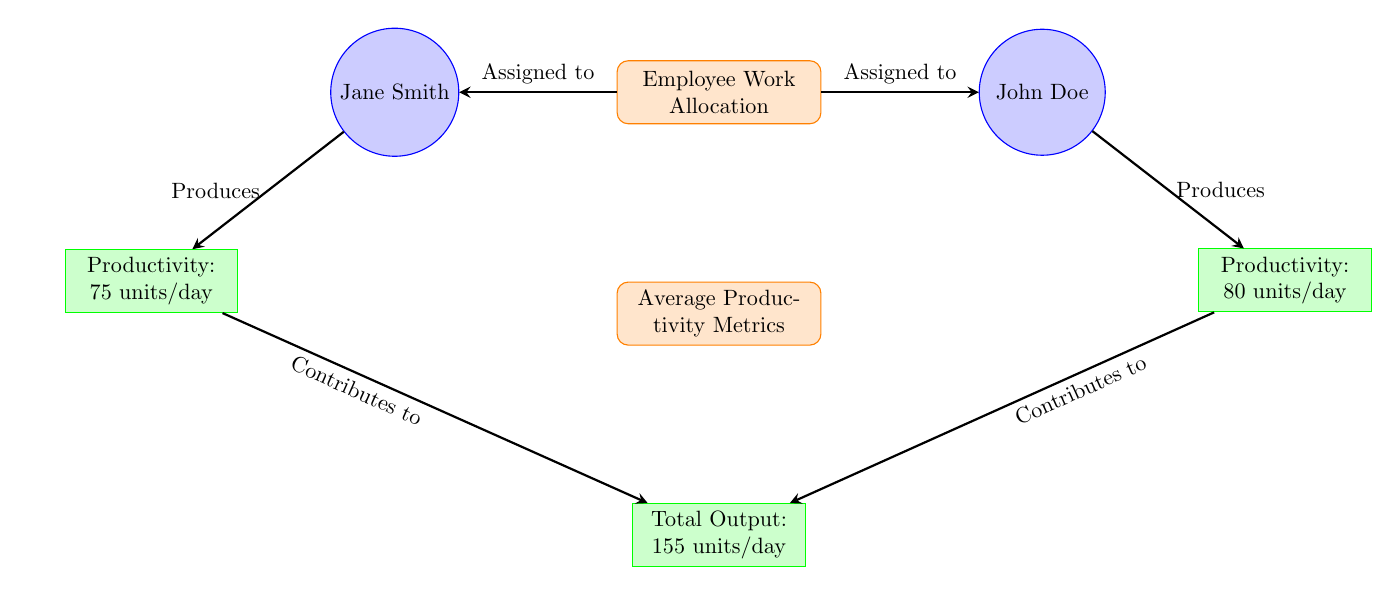What is the productivity of John Doe? In the diagram, the productivity metric linked to John Doe states "Productivity: 80 units/day." Therefore, the value can be extracted directly from this metric.
Answer: 80 units/day What is the productivity of Jane Smith? The diagram shows Jane Smith's productivity metric as "Productivity: 75 units/day." This value is explicitly indicated next to her entity in the visual.
Answer: 75 units/day How many employees are allocated work in the diagram? The diagram illustrates two entities (John Doe and Jane Smith) that are both assigned to the employee work allocation. Hence, the total number of employees is two.
Answer: 2 What is the total output from the workers? The total output metric at the bottom of the diagram states "Total Output: 155 units/day." This can be found directly as the last metric shown below the productivity metrics.
Answer: 155 units/day Which employee has a higher productivity? To determine which employee is more productive, we compare the values assigned to each. John Doe has 80 units/day while Jane Smith has 75 units/day, indicating that John Doe is the more productive worker.
Answer: John Doe What contributes the most to the total output according to the diagram? The contributions indicated in the diagram show both workers contributing to the total output; however, the explicit values of their productivity do not separate whose contribution is higher in the total. Therefore, it can be reasoned that both together make up the total output without clear prioritization.
Answer: Both How is the productivity of each worker related to the total output metric? Each worker's productivity directly contributes to the total output metric, as shown by the arrows directing from their individual productivity metrics to the total output metric in the diagram. Hence, both contributions are necessary to sum up to the total output.
Answer: Directly contributes What are the visual representations used for measuring productivity in this diagram? The diagram employs rectangles with rounded corners representing processes and entities, and metrics are represented by standard rectangles. The specific styles denote different parts of the workflow distinctly.
Answer: Rectangles and circles How are the workers connected to the employee work allocation? The relationship is indicated through arrows that lead from the employee work allocation process to each worker, signifying that they are assigned to this allocation. Thus, the connection is direct and flows from allocation to assignment.
Answer: Arrows 